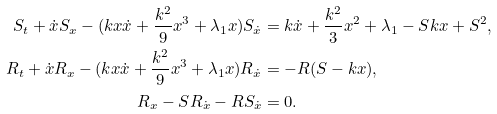<formula> <loc_0><loc_0><loc_500><loc_500>S _ { t } + \dot { x } S _ { x } - ( k x \dot { x } + \frac { k ^ { 2 } } { 9 } x ^ { 3 } + \lambda _ { 1 } x ) S _ { \dot { x } } & = k \dot { x } + \frac { k ^ { 2 } } { 3 } x ^ { 2 } + \lambda _ { 1 } - S k x + S ^ { 2 } , \\ R _ { t } + \dot { x } R _ { x } - ( k x \dot { x } + \frac { k ^ { 2 } } { 9 } x ^ { 3 } + \lambda _ { 1 } x ) R _ { \dot { x } } & = - R ( S - k x ) , \\ R _ { x } - S R _ { \dot { x } } - R S _ { \dot { x } } & = 0 .</formula> 